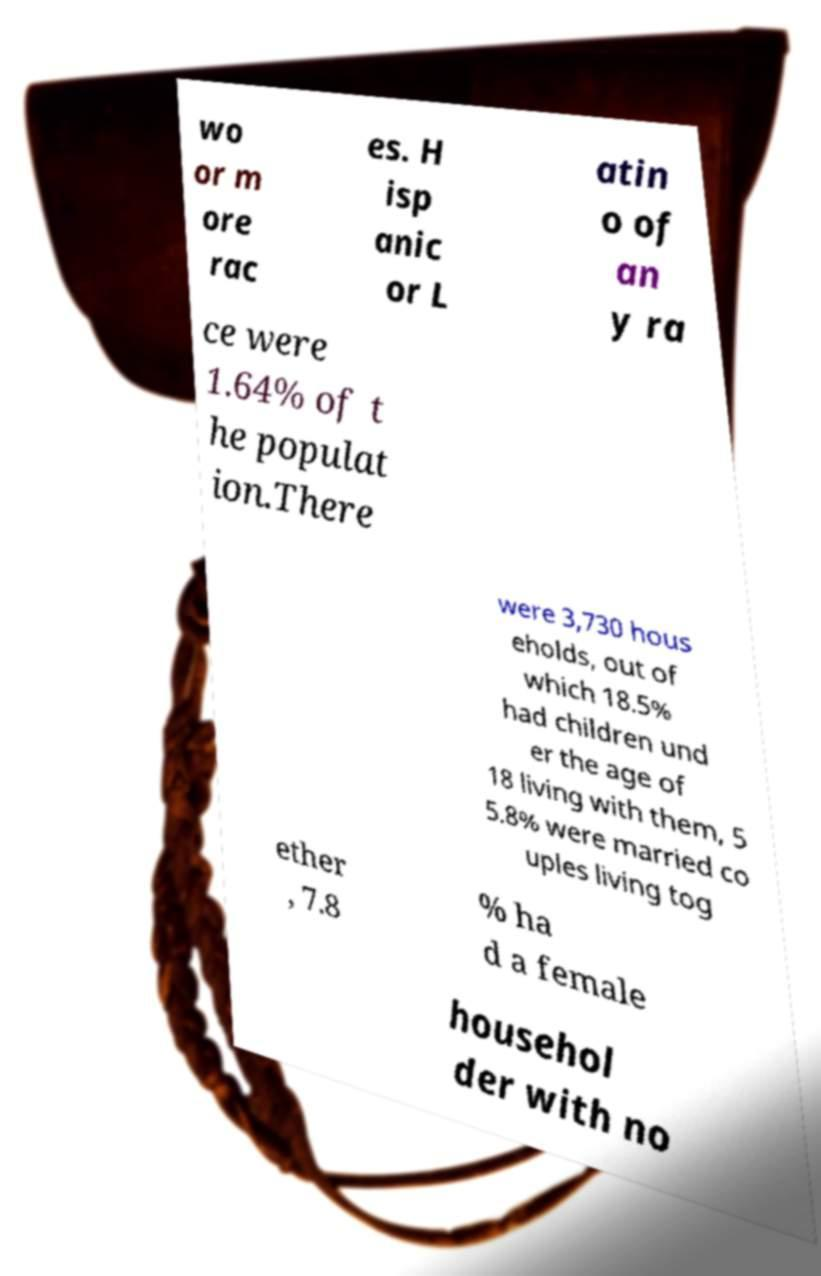What messages or text are displayed in this image? I need them in a readable, typed format. wo or m ore rac es. H isp anic or L atin o of an y ra ce were 1.64% of t he populat ion.There were 3,730 hous eholds, out of which 18.5% had children und er the age of 18 living with them, 5 5.8% were married co uples living tog ether , 7.8 % ha d a female househol der with no 